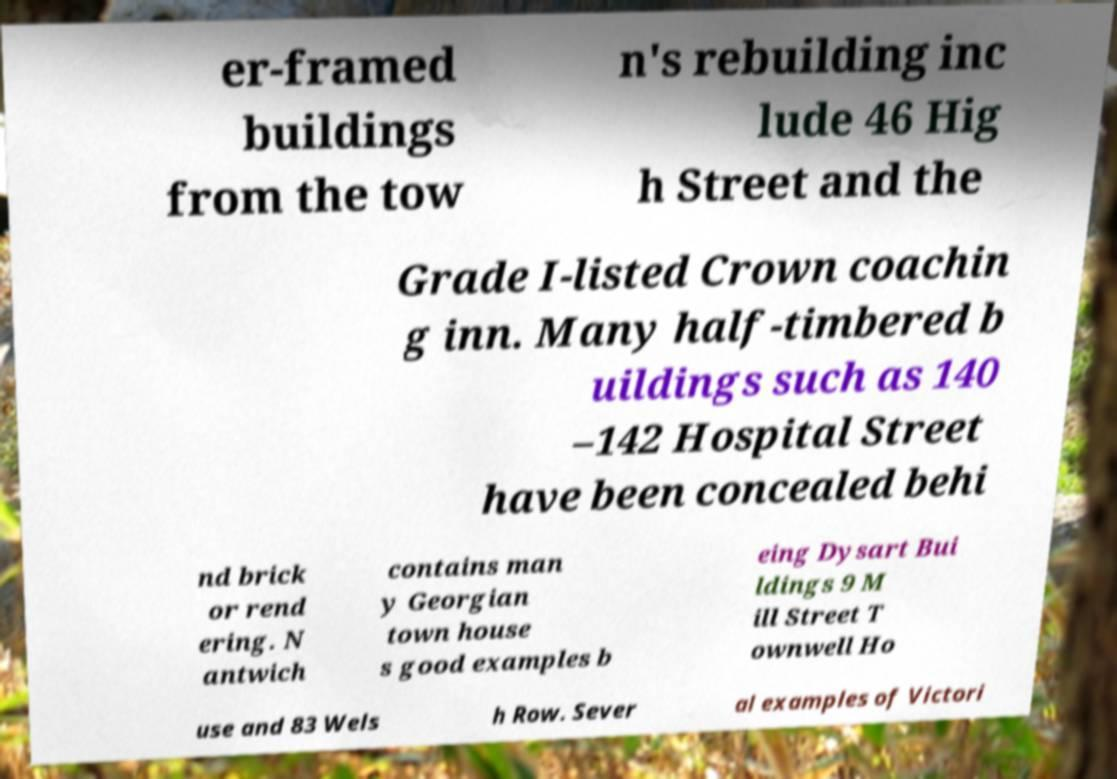I need the written content from this picture converted into text. Can you do that? er-framed buildings from the tow n's rebuilding inc lude 46 Hig h Street and the Grade I-listed Crown coachin g inn. Many half-timbered b uildings such as 140 –142 Hospital Street have been concealed behi nd brick or rend ering. N antwich contains man y Georgian town house s good examples b eing Dysart Bui ldings 9 M ill Street T ownwell Ho use and 83 Wels h Row. Sever al examples of Victori 